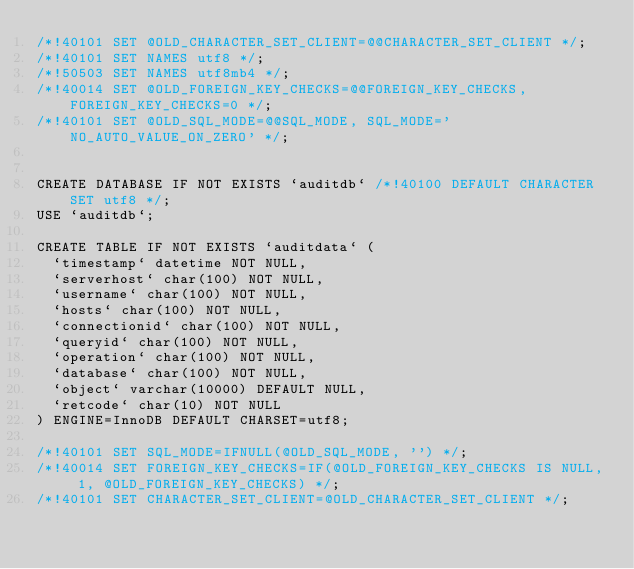<code> <loc_0><loc_0><loc_500><loc_500><_SQL_>/*!40101 SET @OLD_CHARACTER_SET_CLIENT=@@CHARACTER_SET_CLIENT */;
/*!40101 SET NAMES utf8 */;
/*!50503 SET NAMES utf8mb4 */;
/*!40014 SET @OLD_FOREIGN_KEY_CHECKS=@@FOREIGN_KEY_CHECKS, FOREIGN_KEY_CHECKS=0 */;
/*!40101 SET @OLD_SQL_MODE=@@SQL_MODE, SQL_MODE='NO_AUTO_VALUE_ON_ZERO' */;


CREATE DATABASE IF NOT EXISTS `auditdb` /*!40100 DEFAULT CHARACTER SET utf8 */;
USE `auditdb`;

CREATE TABLE IF NOT EXISTS `auditdata` (
  `timestamp` datetime NOT NULL,
  `serverhost` char(100) NOT NULL,
  `username` char(100) NOT NULL,
  `hosts` char(100) NOT NULL,
  `connectionid` char(100) NOT NULL,
  `queryid` char(100) NOT NULL,
  `operation` char(100) NOT NULL,
  `database` char(100) NOT NULL,
  `object` varchar(10000) DEFAULT NULL,
  `retcode` char(10) NOT NULL
) ENGINE=InnoDB DEFAULT CHARSET=utf8;

/*!40101 SET SQL_MODE=IFNULL(@OLD_SQL_MODE, '') */;
/*!40014 SET FOREIGN_KEY_CHECKS=IF(@OLD_FOREIGN_KEY_CHECKS IS NULL, 1, @OLD_FOREIGN_KEY_CHECKS) */;
/*!40101 SET CHARACTER_SET_CLIENT=@OLD_CHARACTER_SET_CLIENT */;
</code> 